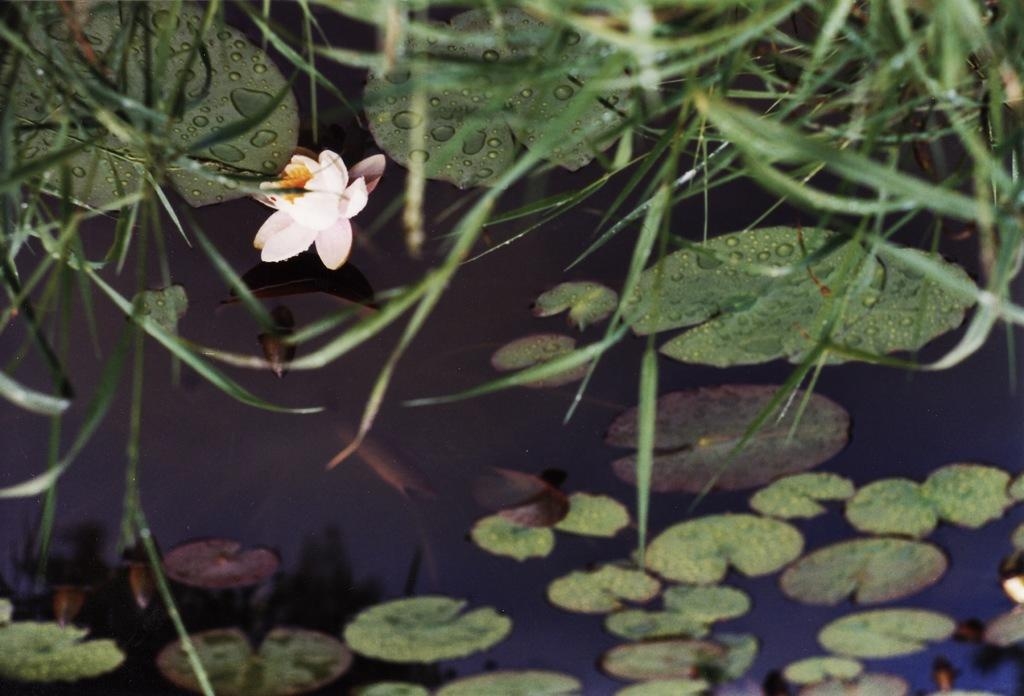What is the primary element in the image? There is water in the image. What type of vegetation can be seen in the image? Leaves, grass, and flowers are visible in the image. What else is present in the image besides water and vegetation? Plants are present in the image. Can you describe the lighting conditions in the image? The image may have been taken during the night. What type of substance is being used to support the coast in the image? There is no coast present in the image, and therefore no substance is being used to support it. 